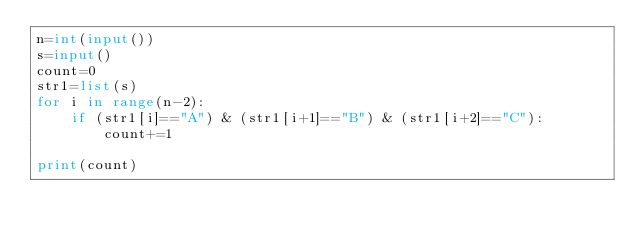<code> <loc_0><loc_0><loc_500><loc_500><_Python_>n=int(input())
s=input()
count=0
str1=list(s)
for i in range(n-2):
    if (str1[i]=="A") & (str1[i+1]=="B") & (str1[i+2]=="C"):
        count+=1
        
print(count)</code> 